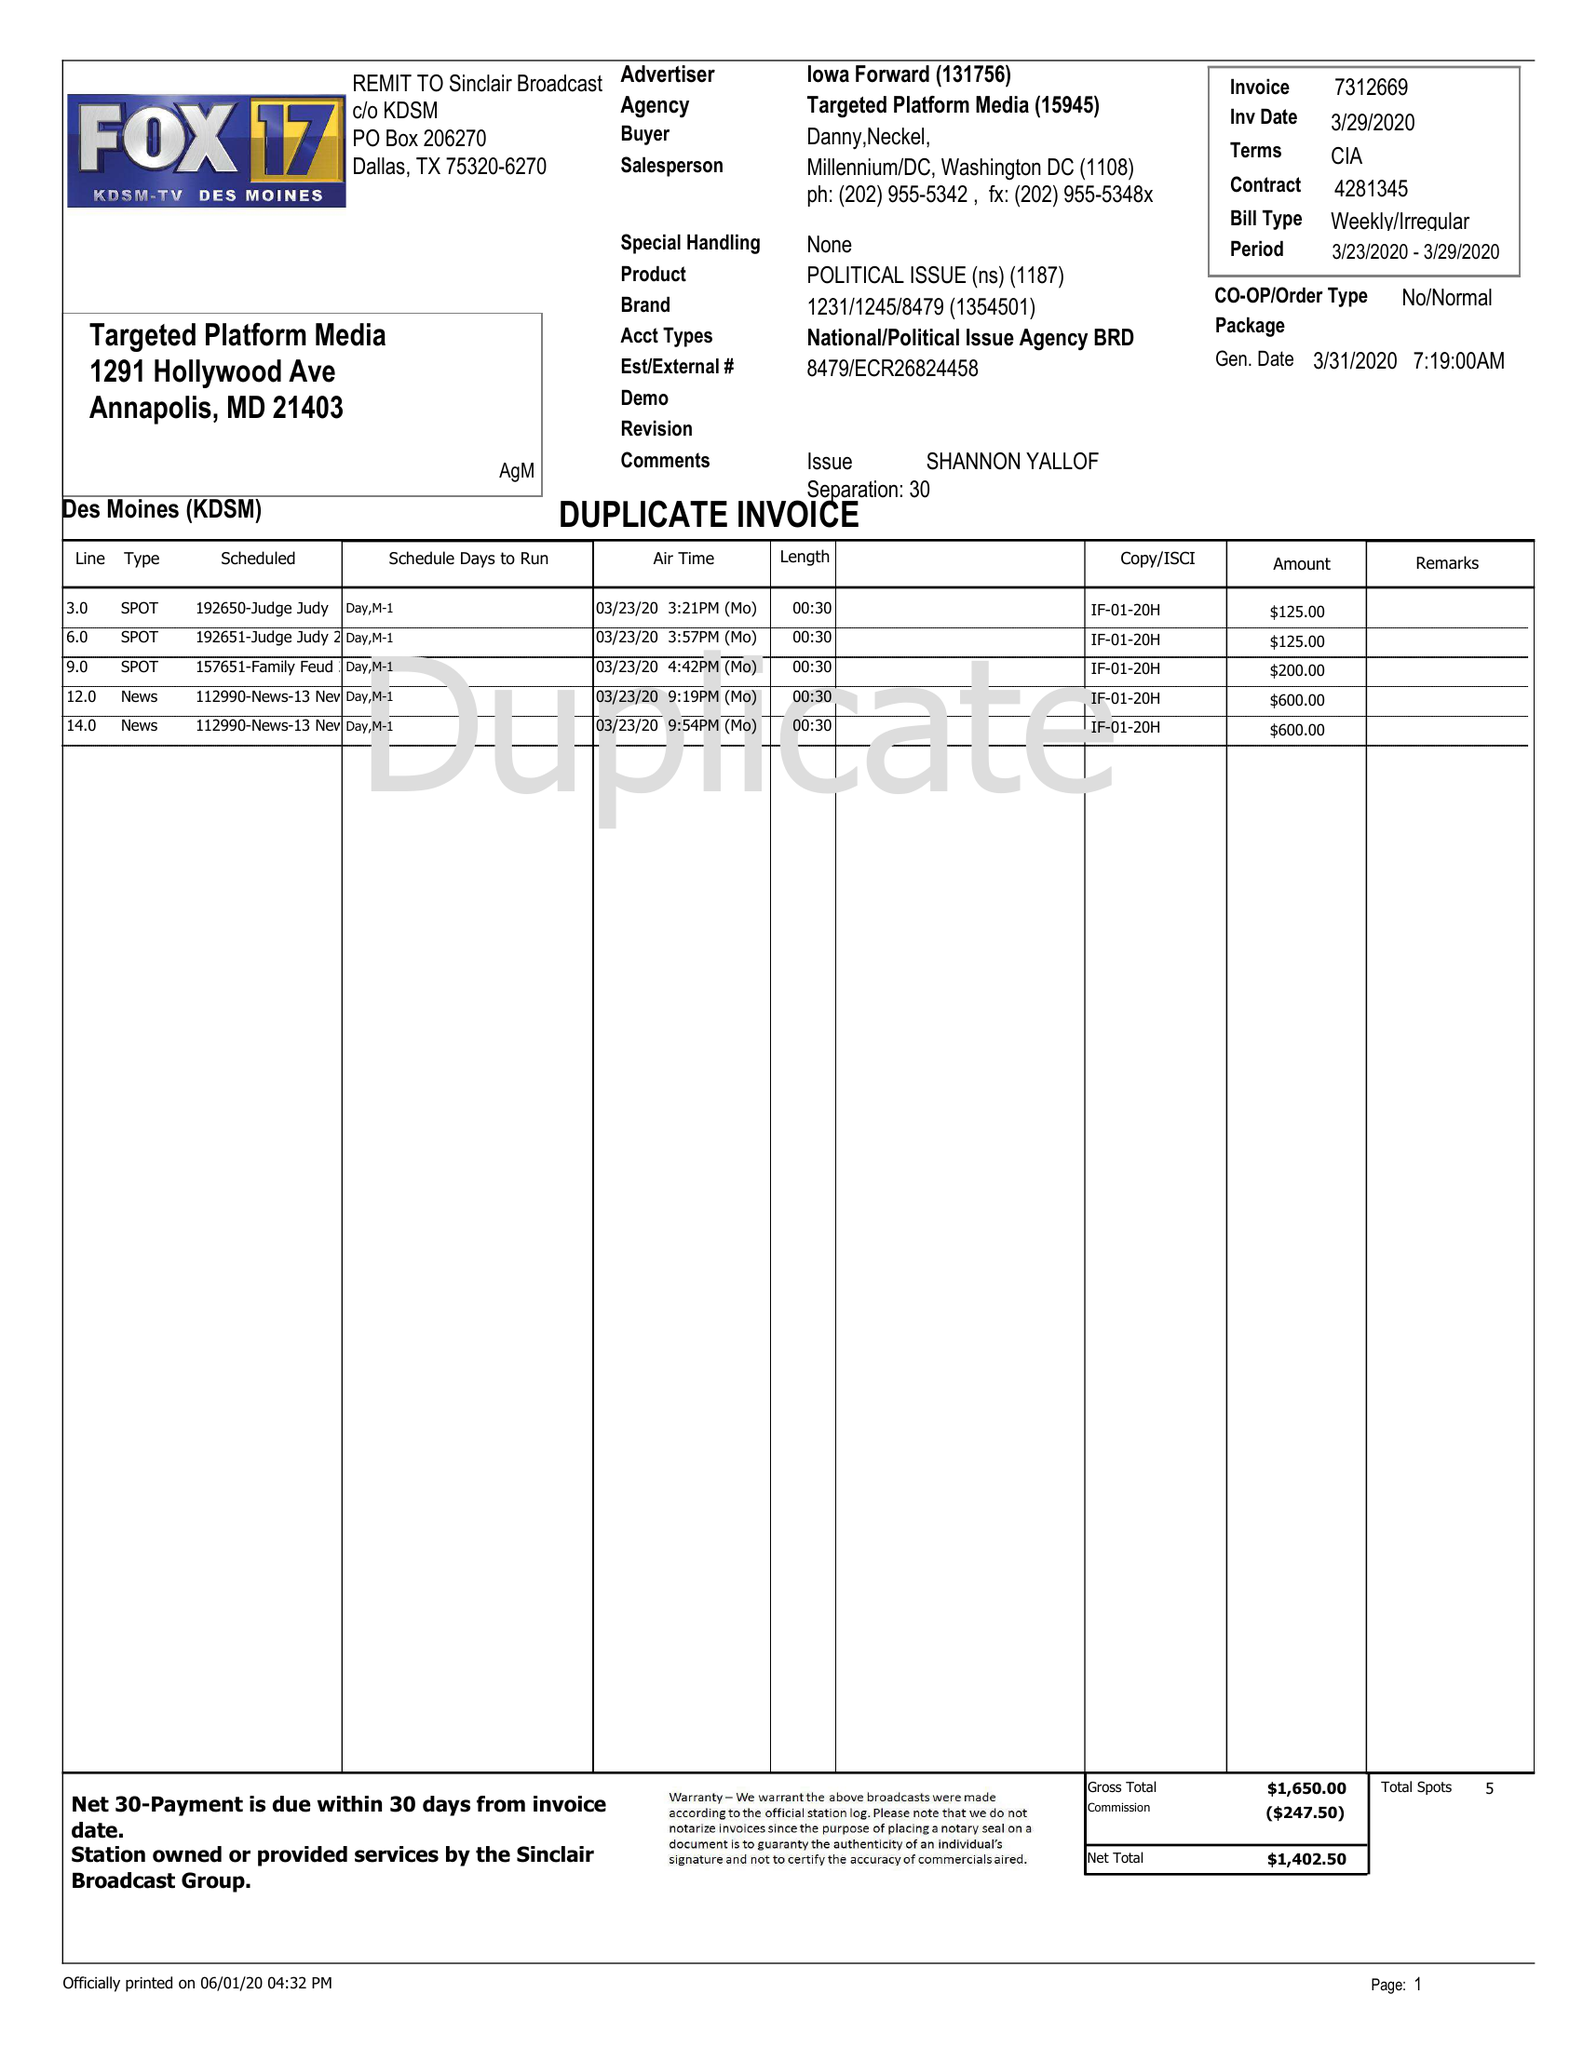What is the value for the advertiser?
Answer the question using a single word or phrase. IOWA FORWARD 